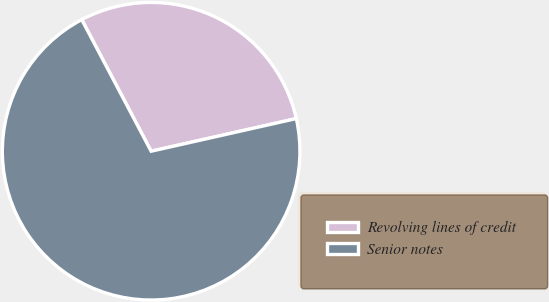<chart> <loc_0><loc_0><loc_500><loc_500><pie_chart><fcel>Revolving lines of credit<fcel>Senior notes<nl><fcel>29.2%<fcel>70.8%<nl></chart> 